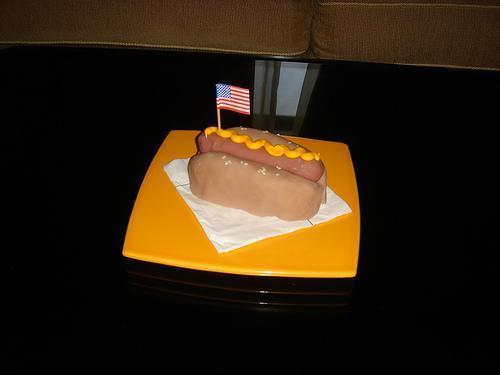How many baby giraffes are there?
Give a very brief answer. 0. 